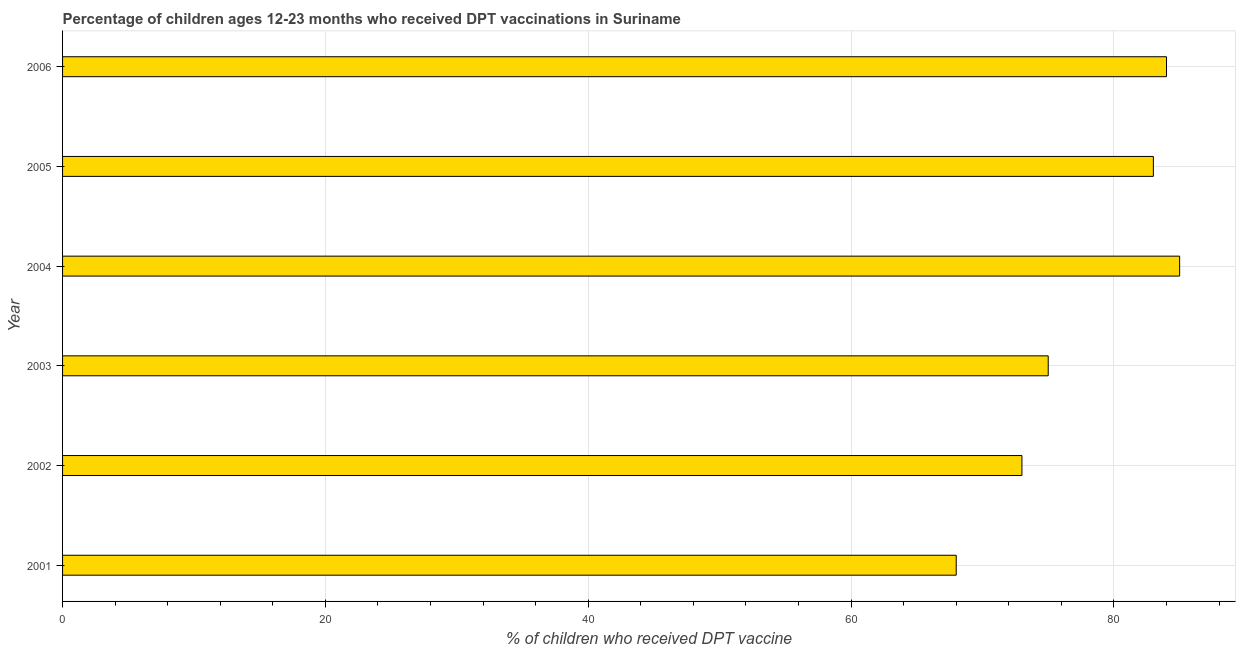Does the graph contain grids?
Offer a very short reply. Yes. What is the title of the graph?
Your response must be concise. Percentage of children ages 12-23 months who received DPT vaccinations in Suriname. What is the label or title of the X-axis?
Keep it short and to the point. % of children who received DPT vaccine. What is the label or title of the Y-axis?
Make the answer very short. Year. In which year was the percentage of children who received dpt vaccine maximum?
Offer a terse response. 2004. In which year was the percentage of children who received dpt vaccine minimum?
Keep it short and to the point. 2001. What is the sum of the percentage of children who received dpt vaccine?
Ensure brevity in your answer.  468. What is the difference between the percentage of children who received dpt vaccine in 2004 and 2006?
Provide a short and direct response. 1. What is the median percentage of children who received dpt vaccine?
Provide a succinct answer. 79. Do a majority of the years between 2003 and 2006 (inclusive) have percentage of children who received dpt vaccine greater than 48 %?
Offer a very short reply. Yes. What is the ratio of the percentage of children who received dpt vaccine in 2001 to that in 2004?
Your answer should be very brief. 0.8. Is the percentage of children who received dpt vaccine in 2002 less than that in 2005?
Ensure brevity in your answer.  Yes. What is the difference between the highest and the second highest percentage of children who received dpt vaccine?
Your response must be concise. 1. What is the difference between the highest and the lowest percentage of children who received dpt vaccine?
Provide a short and direct response. 17. Are all the bars in the graph horizontal?
Offer a terse response. Yes. What is the difference between two consecutive major ticks on the X-axis?
Your answer should be compact. 20. Are the values on the major ticks of X-axis written in scientific E-notation?
Provide a short and direct response. No. What is the % of children who received DPT vaccine of 2001?
Ensure brevity in your answer.  68. What is the % of children who received DPT vaccine in 2003?
Offer a terse response. 75. What is the % of children who received DPT vaccine in 2004?
Offer a terse response. 85. What is the % of children who received DPT vaccine of 2005?
Offer a terse response. 83. What is the difference between the % of children who received DPT vaccine in 2001 and 2002?
Ensure brevity in your answer.  -5. What is the difference between the % of children who received DPT vaccine in 2001 and 2003?
Your answer should be very brief. -7. What is the difference between the % of children who received DPT vaccine in 2001 and 2006?
Offer a terse response. -16. What is the difference between the % of children who received DPT vaccine in 2002 and 2004?
Ensure brevity in your answer.  -12. What is the difference between the % of children who received DPT vaccine in 2002 and 2005?
Offer a very short reply. -10. What is the difference between the % of children who received DPT vaccine in 2003 and 2004?
Offer a very short reply. -10. What is the difference between the % of children who received DPT vaccine in 2003 and 2005?
Offer a very short reply. -8. What is the difference between the % of children who received DPT vaccine in 2005 and 2006?
Your response must be concise. -1. What is the ratio of the % of children who received DPT vaccine in 2001 to that in 2002?
Ensure brevity in your answer.  0.93. What is the ratio of the % of children who received DPT vaccine in 2001 to that in 2003?
Your response must be concise. 0.91. What is the ratio of the % of children who received DPT vaccine in 2001 to that in 2005?
Your answer should be compact. 0.82. What is the ratio of the % of children who received DPT vaccine in 2001 to that in 2006?
Provide a short and direct response. 0.81. What is the ratio of the % of children who received DPT vaccine in 2002 to that in 2004?
Your answer should be compact. 0.86. What is the ratio of the % of children who received DPT vaccine in 2002 to that in 2006?
Offer a terse response. 0.87. What is the ratio of the % of children who received DPT vaccine in 2003 to that in 2004?
Provide a succinct answer. 0.88. What is the ratio of the % of children who received DPT vaccine in 2003 to that in 2005?
Provide a short and direct response. 0.9. What is the ratio of the % of children who received DPT vaccine in 2003 to that in 2006?
Give a very brief answer. 0.89. What is the ratio of the % of children who received DPT vaccine in 2004 to that in 2005?
Provide a succinct answer. 1.02. What is the ratio of the % of children who received DPT vaccine in 2004 to that in 2006?
Give a very brief answer. 1.01. What is the ratio of the % of children who received DPT vaccine in 2005 to that in 2006?
Keep it short and to the point. 0.99. 